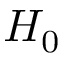<formula> <loc_0><loc_0><loc_500><loc_500>H _ { 0 }</formula> 